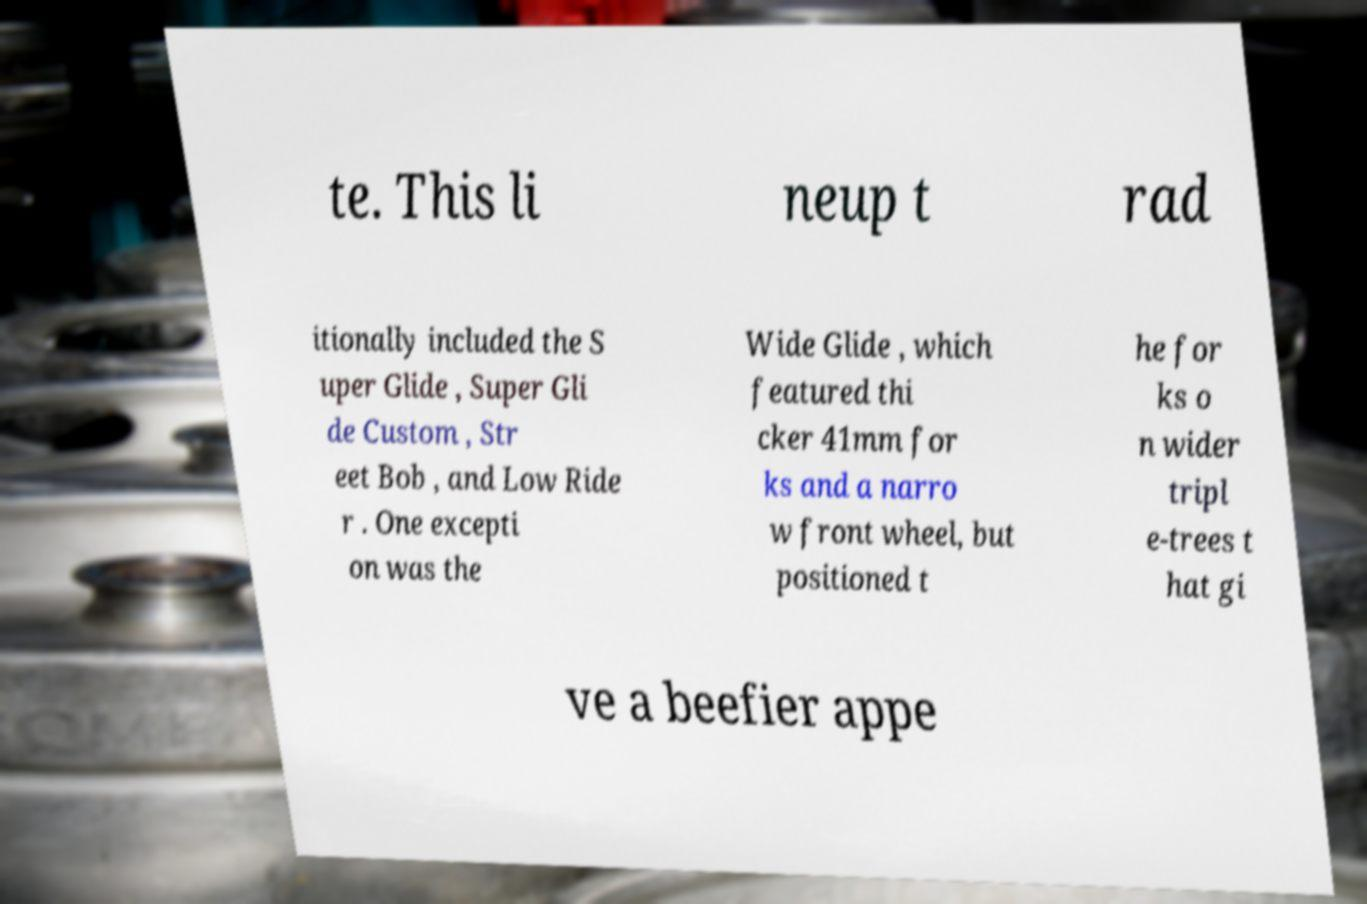Can you accurately transcribe the text from the provided image for me? te. This li neup t rad itionally included the S uper Glide , Super Gli de Custom , Str eet Bob , and Low Ride r . One excepti on was the Wide Glide , which featured thi cker 41mm for ks and a narro w front wheel, but positioned t he for ks o n wider tripl e-trees t hat gi ve a beefier appe 